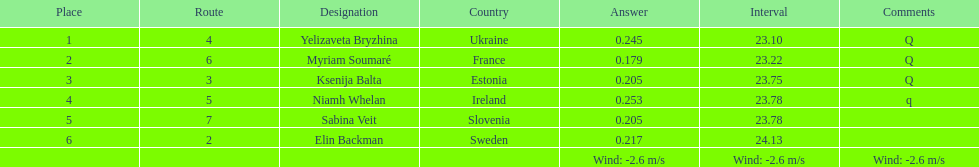Are any of the lanes in consecutive order? No. 